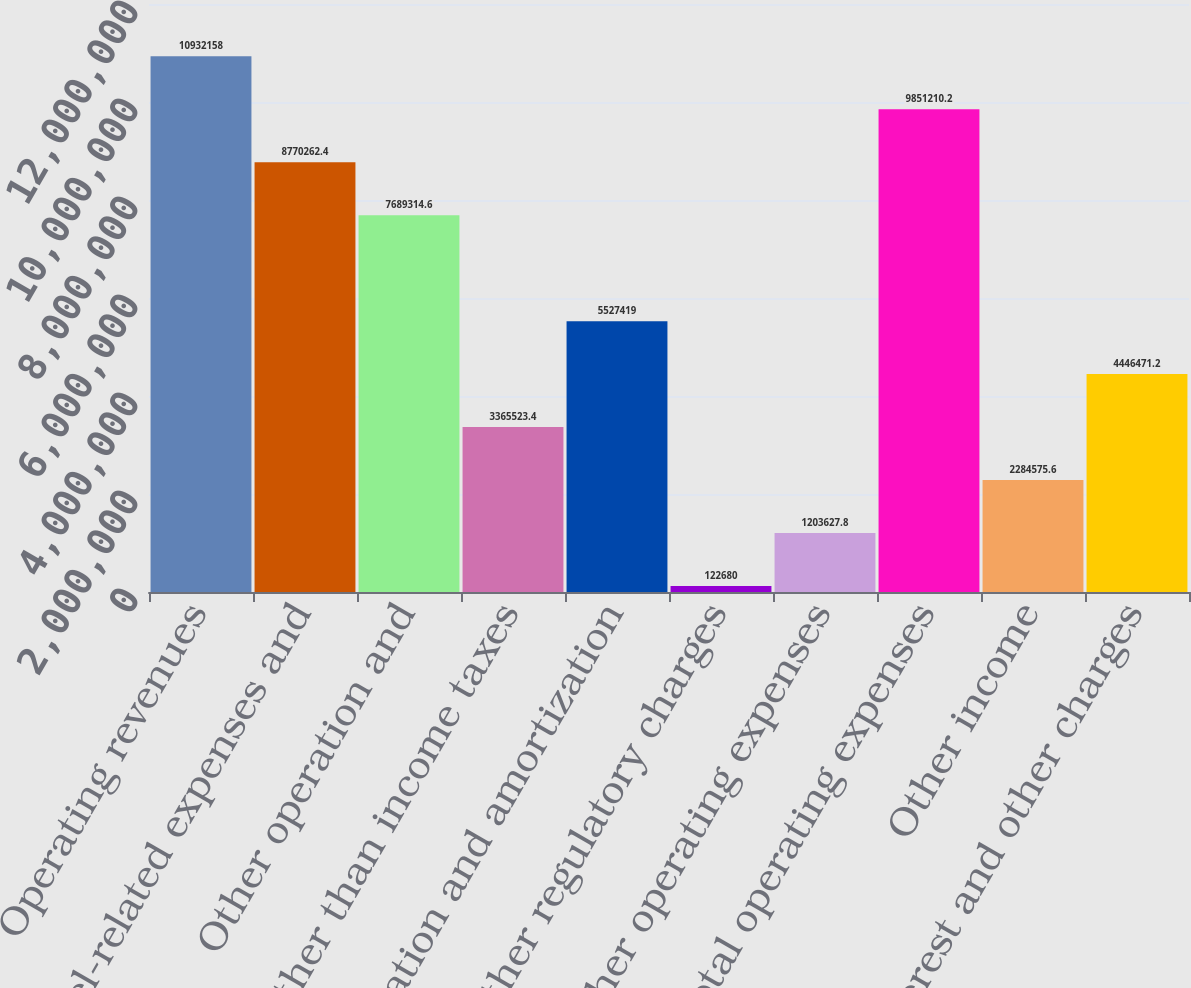<chart> <loc_0><loc_0><loc_500><loc_500><bar_chart><fcel>Operating revenues<fcel>Fuel fuel-related expenses and<fcel>Other operation and<fcel>Taxes other than income taxes<fcel>Depreciation and amortization<fcel>Other regulatory charges<fcel>Other operating expenses<fcel>Total operating expenses<fcel>Other income<fcel>Interest and other charges<nl><fcel>1.09322e+07<fcel>8.77026e+06<fcel>7.68931e+06<fcel>3.36552e+06<fcel>5.52742e+06<fcel>122680<fcel>1.20363e+06<fcel>9.85121e+06<fcel>2.28458e+06<fcel>4.44647e+06<nl></chart> 